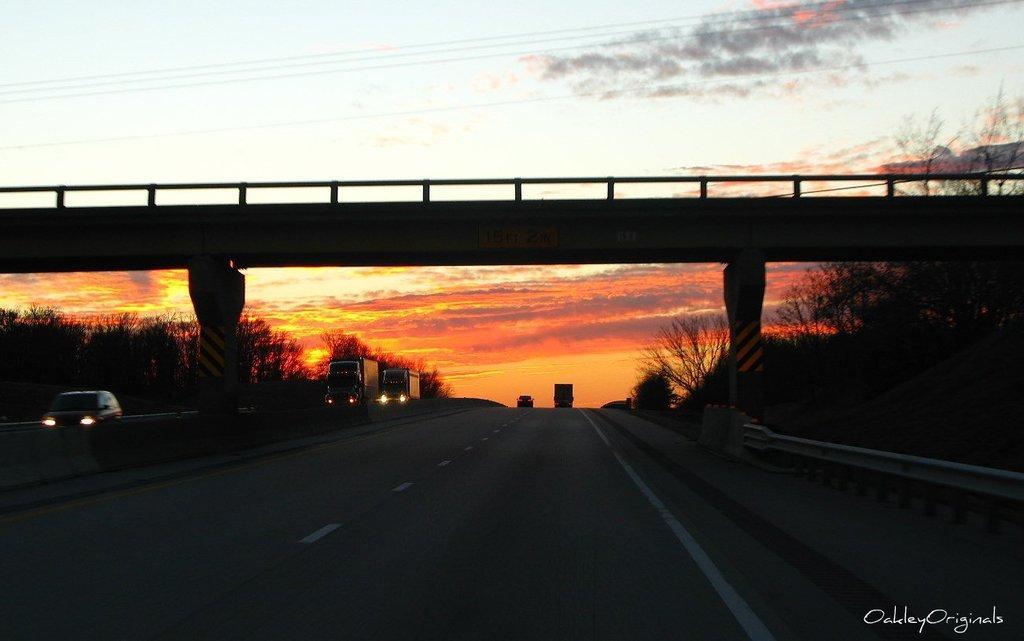Can you describe this image briefly? In this picture we can observe a bridge. There are two pillars. We can observe a road on which there are some vehicles moving. We can observe trees on either sides of this road. In the background we can observe a sky which is in orange and blue color. 